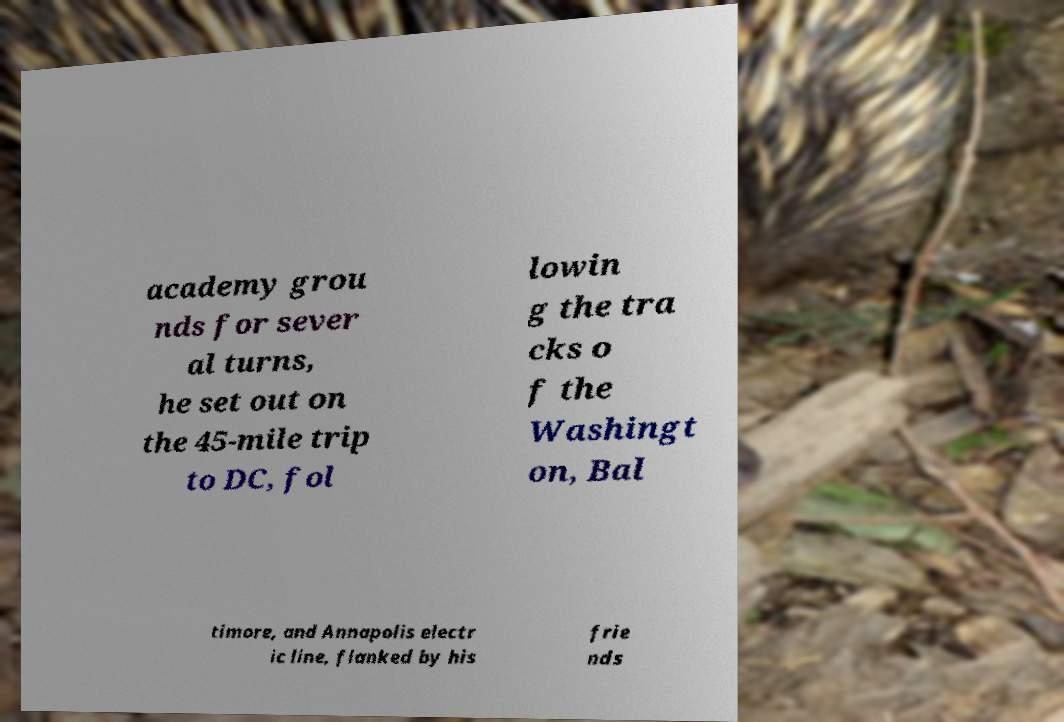There's text embedded in this image that I need extracted. Can you transcribe it verbatim? academy grou nds for sever al turns, he set out on the 45-mile trip to DC, fol lowin g the tra cks o f the Washingt on, Bal timore, and Annapolis electr ic line, flanked by his frie nds 